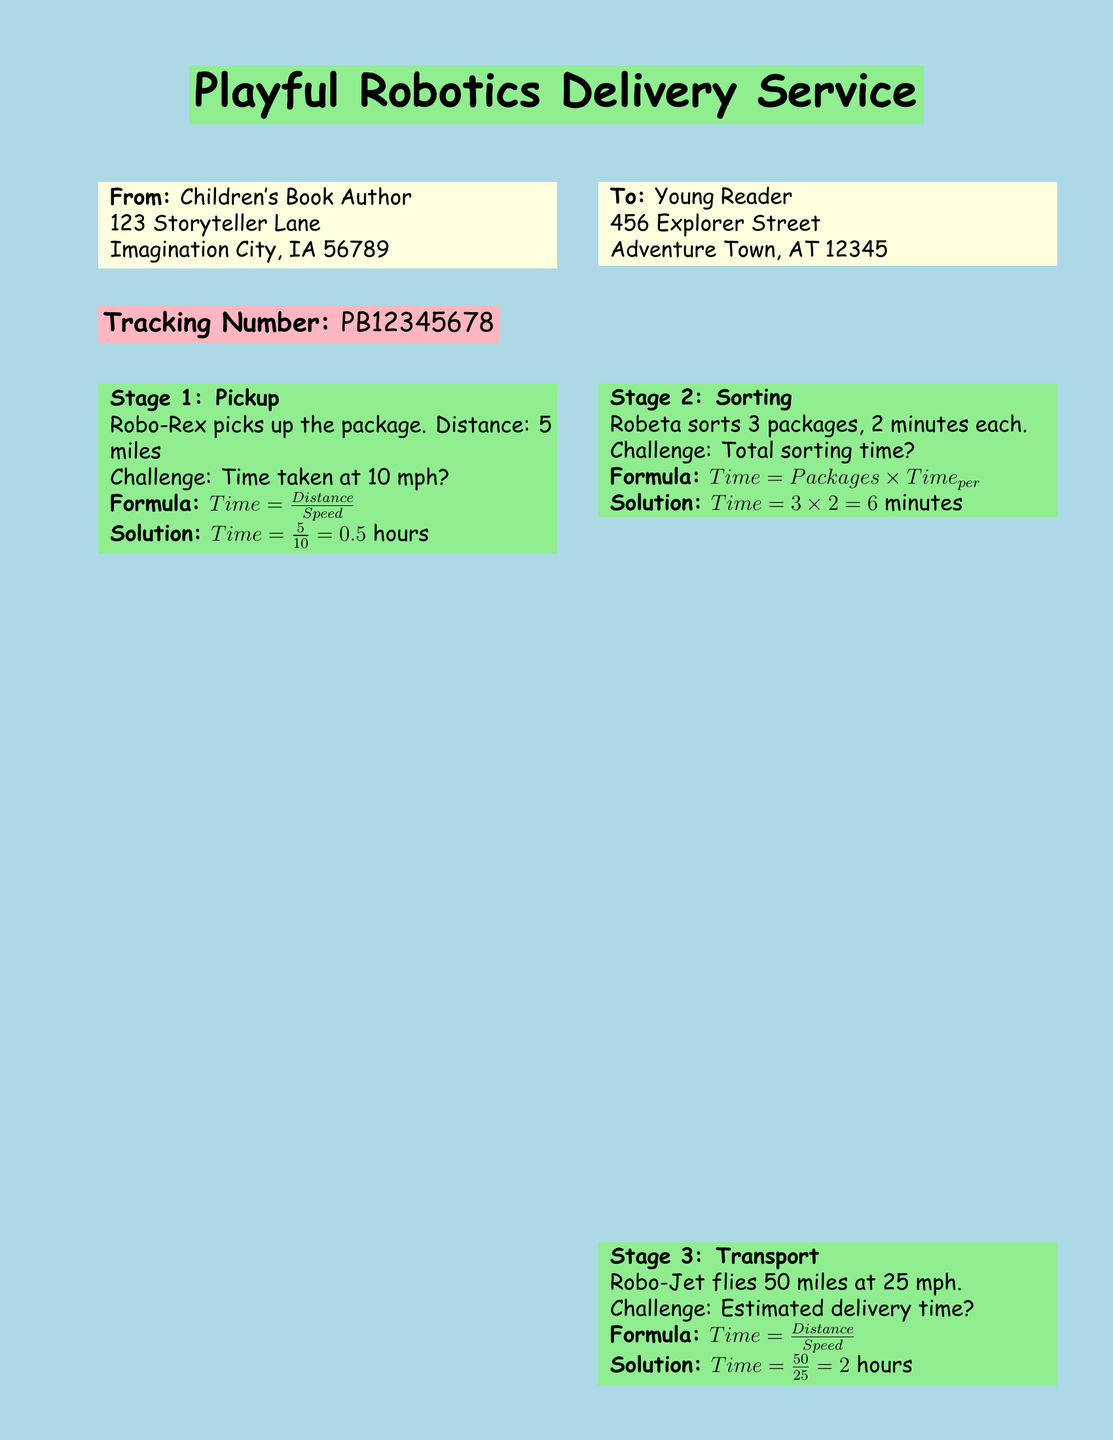What is the tracking number? The tracking number is a unique identifier for the package, which is PB12345678.
Answer: PB12345678 Who is the sender? The sender's name can be found in the "From" section, which lists "Children's Book Author."
Answer: Children's Book Author What is the total sorting time? The sorting time is calculated based on the time taken for each package, resulting in 6 minutes total.
Answer: 6 minutes How far does Robo-Rex travel in Stage 1? The distance traveled by Robo-Rex in Stage 1 is specified clearly as 5 miles.
Answer: 5 miles What speed does Robo-Jet fly at? The speed of Robo-Jet during transport is indicated as 25 mph.
Answer: 25 mph What is the distance for the last delivery stage? The last stage of delivery specifies that the distance traveled is 1 mile.
Answer: 1 mile How long does it take Robo-Friend to deliver the package? The delivery time for Robo-Friend is calculated and noted as 0.25 hours.
Answer: 0.25 hours What mathematical formula is used for calculating time in transport? The formula to calculate time in transport stages is provided as Time = Distance / Speed.
Answer: Time = Distance / Speed What color represents the title of the shipping service? The title of the shipping service is displayed on a light green background.
Answer: Light green 